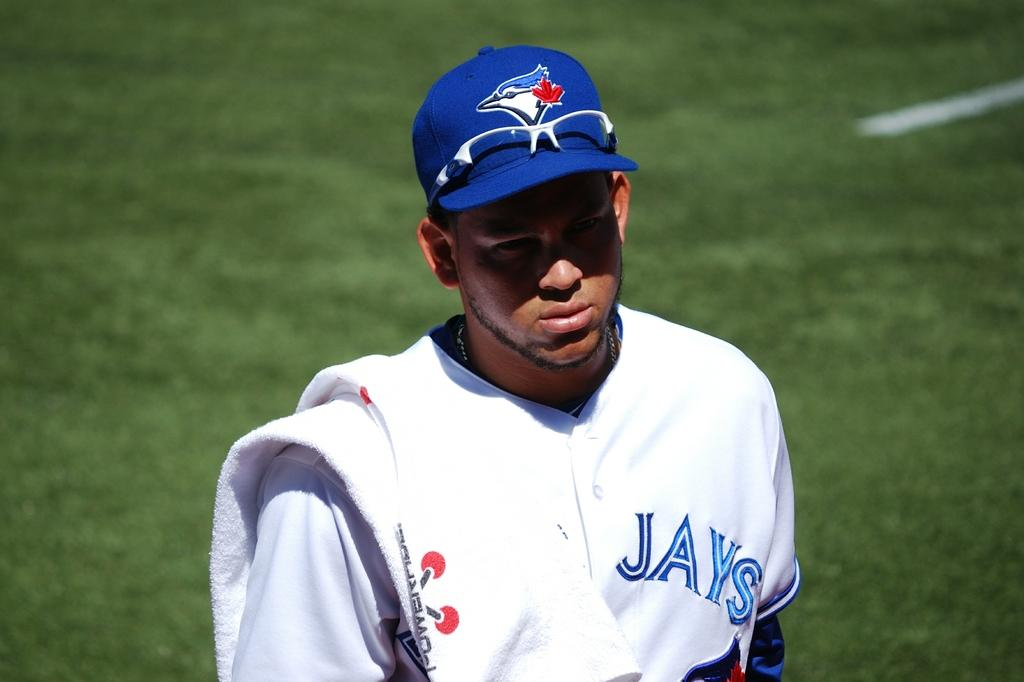Provide a one-sentence caption for the provided image. A player wears a blue hat and a white shirt with "Jays" in blue letters. 